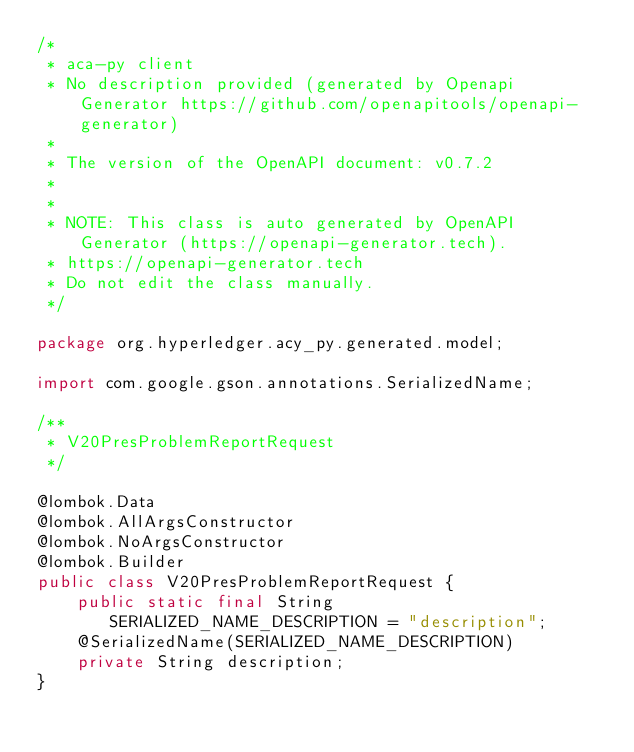Convert code to text. <code><loc_0><loc_0><loc_500><loc_500><_Java_>/*
 * aca-py client
 * No description provided (generated by Openapi Generator https://github.com/openapitools/openapi-generator)
 *
 * The version of the OpenAPI document: v0.7.2
 * 
 *
 * NOTE: This class is auto generated by OpenAPI Generator (https://openapi-generator.tech).
 * https://openapi-generator.tech
 * Do not edit the class manually.
 */

package org.hyperledger.acy_py.generated.model;

import com.google.gson.annotations.SerializedName;

/**
 * V20PresProblemReportRequest
 */

@lombok.Data
@lombok.AllArgsConstructor
@lombok.NoArgsConstructor
@lombok.Builder
public class V20PresProblemReportRequest {
    public static final String SERIALIZED_NAME_DESCRIPTION = "description";
    @SerializedName(SERIALIZED_NAME_DESCRIPTION)
    private String description;
}
</code> 